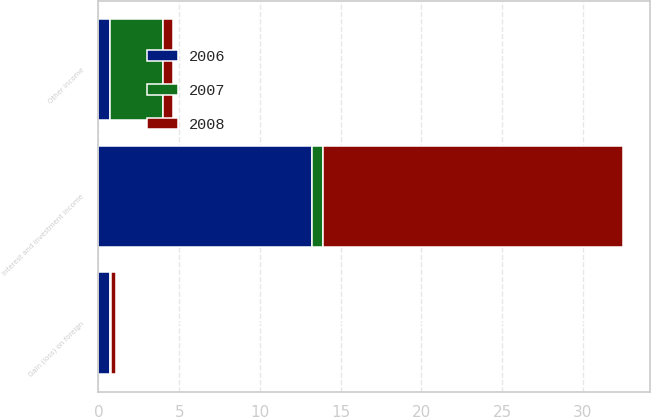Convert chart to OTSL. <chart><loc_0><loc_0><loc_500><loc_500><stacked_bar_chart><ecel><fcel>Interest and investment income<fcel>Gain (loss) on foreign<fcel>Other income<nl><fcel>2007<fcel>0.7<fcel>0.1<fcel>3.3<nl><fcel>2008<fcel>18.6<fcel>0.3<fcel>0.6<nl><fcel>2006<fcel>13.2<fcel>0.7<fcel>0.7<nl></chart> 